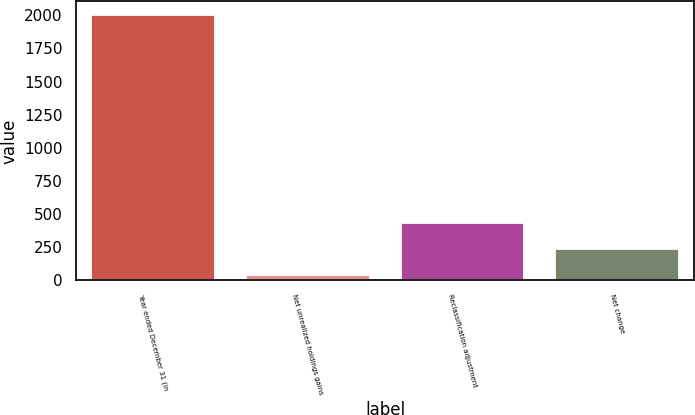Convert chart. <chart><loc_0><loc_0><loc_500><loc_500><bar_chart><fcel>Year ended December 31 (in<fcel>Net unrealized holdings gains<fcel>Reclassification adjustment<fcel>Net change<nl><fcel>2004<fcel>41<fcel>433.6<fcel>237.3<nl></chart> 